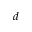<formula> <loc_0><loc_0><loc_500><loc_500>d</formula> 